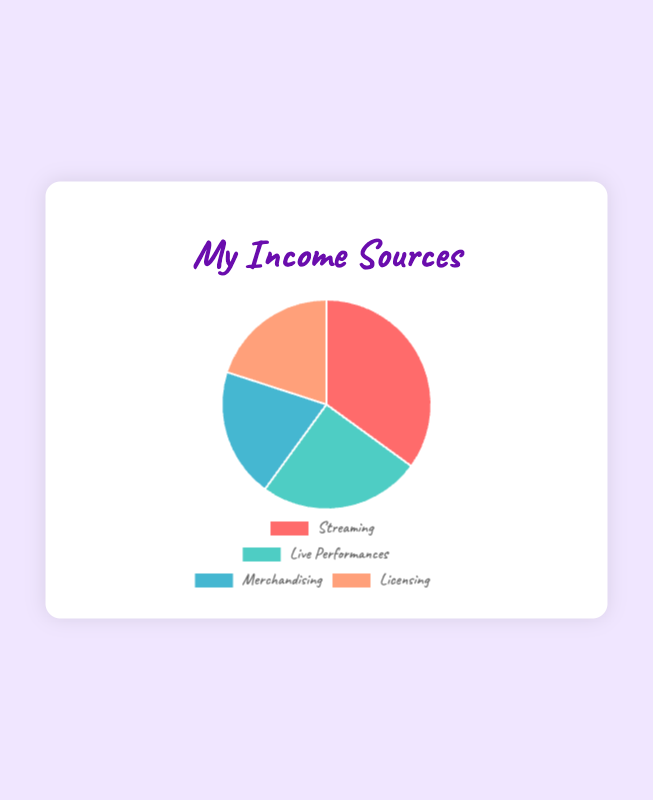Which source of income has the highest percentage? By looking at the pie chart, you can see that the category with the largest slice represents the highest percentage. The slice labeled "Streaming" is the largest with 35%.
Answer: Streaming How much higher is the percentage of Streaming compared to Merchandising? The percentage for Streaming is 35% and for Merchandising is 20%. Subtract the percentage of Merchandising from Streaming (35% - 20%), resulting in the difference.
Answer: 15% What's the combined percentage of Merchandising and Licensing? Add the percentages of Merchandising (20%) and Licensing (20%). The combined percentage is 20% + 20% = 40%.
Answer: 40% Which two sources of income are equal in percentage? By examining the pie chart, you can observe that the slices for Merchandising and Licensing are of equal size, both representing 20%.
Answer: Merchandising and Licensing Which data source occupies a green slice in the pie chart? The pie chart uses different colors for each category, and by identifying the green slice, you find that it represents Live Performances.
Answer: Live Performances Between Live Performances and Licensing, which source has a lower percentage? By comparing the two slices, you can see that Live Performances represent 25% while Licensing is 20%. Therefore, the source with the lower percentage is Licensing.
Answer: Licensing If Streaming and Live Performances combined their percentages, what fraction of the total income would they represent? First, add the percentages of Streaming (35%) and Live Performances (25%). The total is 35% + 25% = 60%. This can be expressed as the fraction 60/100, which simplifies to 3/5.
Answer: 3/5 What color represents the Licensing income in the pie chart? Each income source is represented using a different color. The color used for Licensing is a light orange.
Answer: light orange 